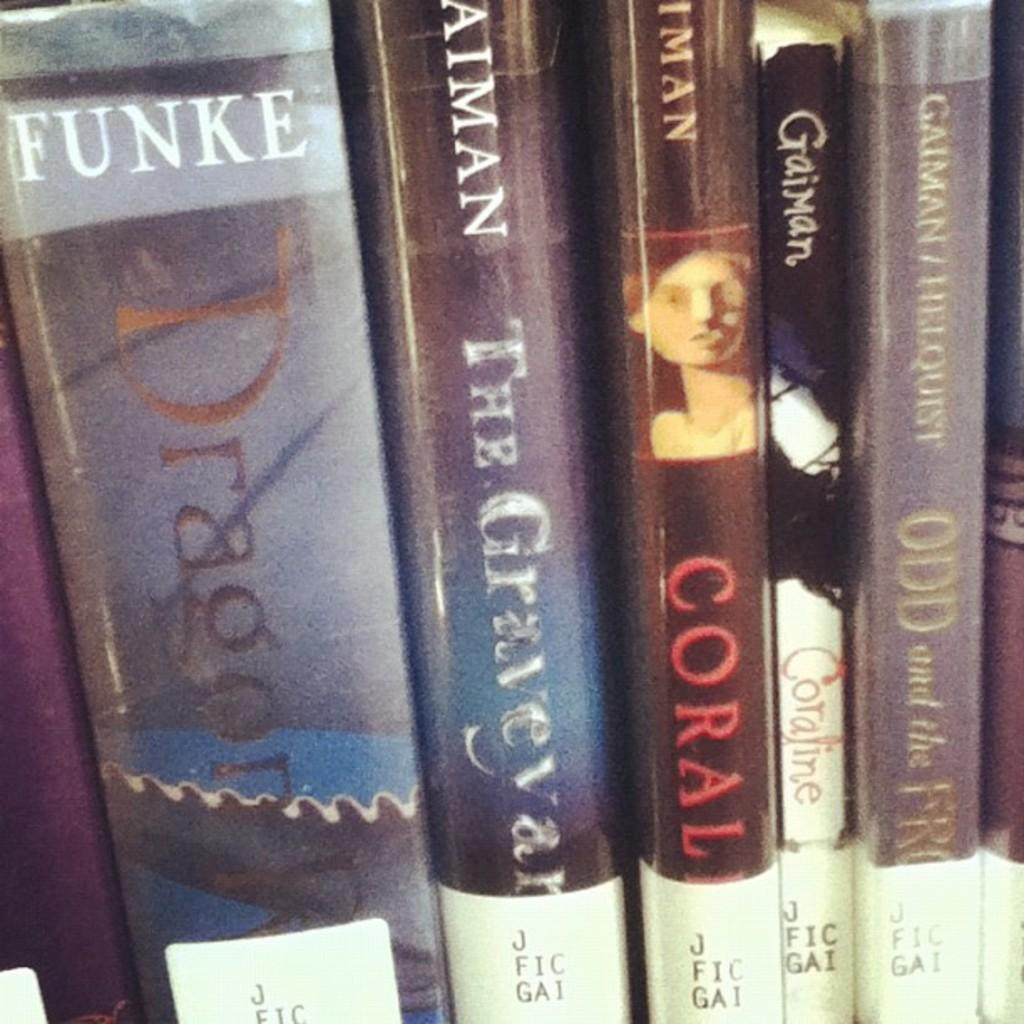<image>
Render a clear and concise summary of the photo. A row of books including The Graveyard by Aiman. 